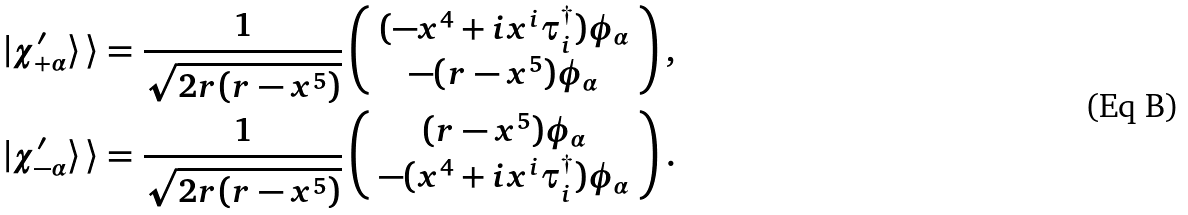<formula> <loc_0><loc_0><loc_500><loc_500>& | \chi ^ { \prime } _ { + \alpha } \rangle \, \rangle = \frac { 1 } { \sqrt { 2 r ( r - x ^ { 5 } ) } } \left ( \begin{array} { c } ( - x ^ { 4 } + i x ^ { i } \tau _ { i } ^ { \dagger } ) \phi _ { \alpha } \\ - ( r - x ^ { 5 } ) \phi _ { \alpha } \end{array} \right ) , \\ & | \chi ^ { \prime } _ { - \alpha } \rangle \, \rangle = \frac { 1 } { \sqrt { 2 r ( r - x ^ { 5 } ) } } \left ( \begin{array} { c } ( r - x ^ { 5 } ) \phi _ { \alpha } \\ - ( x ^ { 4 } + i x ^ { i } \tau _ { i } ^ { \dagger } ) \phi _ { \alpha } \end{array} \right ) .</formula> 